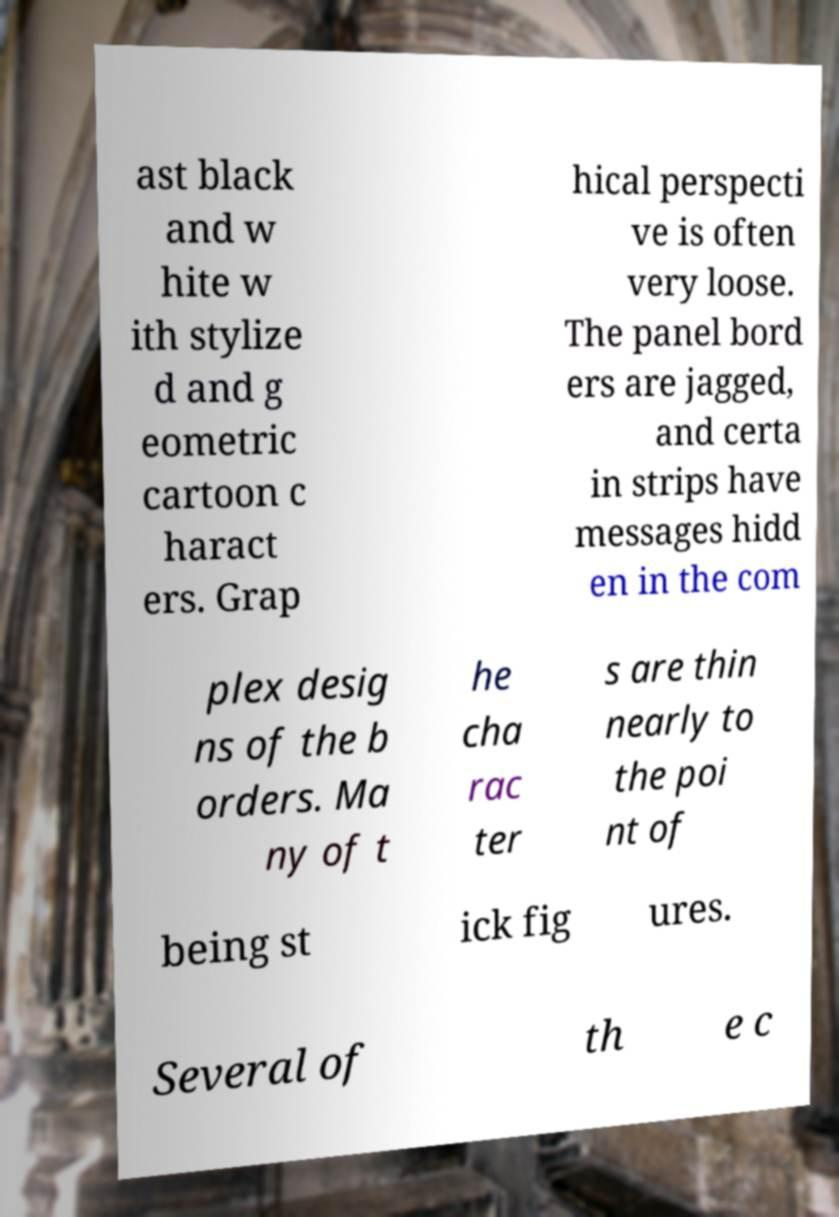Could you extract and type out the text from this image? ast black and w hite w ith stylize d and g eometric cartoon c haract ers. Grap hical perspecti ve is often very loose. The panel bord ers are jagged, and certa in strips have messages hidd en in the com plex desig ns of the b orders. Ma ny of t he cha rac ter s are thin nearly to the poi nt of being st ick fig ures. Several of th e c 